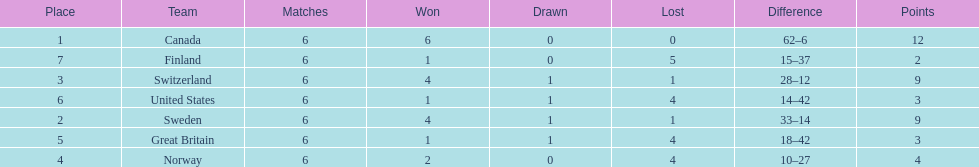What team placed next after sweden? Switzerland. 